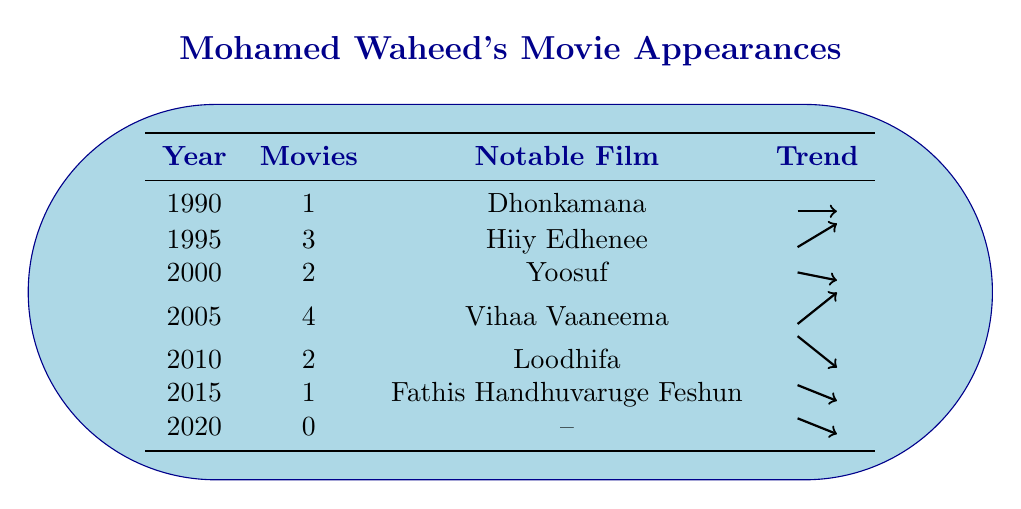What was the notable film of Mohamed Waheed in 2005? According to the table, the year 2005 features the notable film "Vihaa Vaaneema" from Mohamed Waheed's movie appearances.
Answer: Vihaa Vaaneema In which year did Mohamed Waheed have the highest number of movie appearances? Looking at the table, 2005 shows the highest number of movie appearances with a total of 4 movies.
Answer: 2005 How many movies did Mohamed Waheed appear in during the 1990s? Summing the movies from 1990 (1) and 1995 (3) gives a total of 4 movies in the 1990s.
Answer: 4 Did Mohamed Waheed appear in any films in 2020? The table indicates that in 2020, the number of movies was 0, which means he did not appear in any films that year.
Answer: No What is the trend of Mohamed Waheed's movie appearances from 2000 to 2020? From the table, in 2000 he had 2 movies, then it increased to 4 in 2005, dropped to 2 in 2010, 1 in 2015, and 0 in 2020. This shows a fluctuating trend with a decline towards 2020.
Answer: Fluctuating decline How many years did Mohamed Waheed appear in more than 2 movies? Referring to the table, he appeared in more than 2 movies in only one year, which is 2005.
Answer: 1 What is the average number of movie appearances per year from 1990 to 2020? The total number of movies from all listed years is 13 (1 + 3 + 2 + 4 + 2 + 1 + 0) and there are 7 years. Thus, the average is 13/7, which calculates to approximately 1.86.
Answer: Approximately 1.86 Which year had the most drastic change in the number of movies compared to the previous year? Analyzing the changes reveals 2005 to 2010 dropped from 4 to 2, a change of -2; while 2010 to 2015 dropped again from 2 to 1, a change of -1. The year 2005 had the most drastic change with the highest drop.
Answer: 2005 Was there a year where Mohamed Waheed did not release any movies, and if so, which year? The table lists 2020 as the year with 0 movies, confirming that he did not release any movies that year.
Answer: Yes, 2020 What notable film did Mohamed Waheed feature in the year with the fewest movie appearances? In 2015, Mohamed Waheed had only 1 movie appearance, which was "Fathis Handhuvaruge Feshun."
Answer: Fathis Handhuvaruge Feshun 